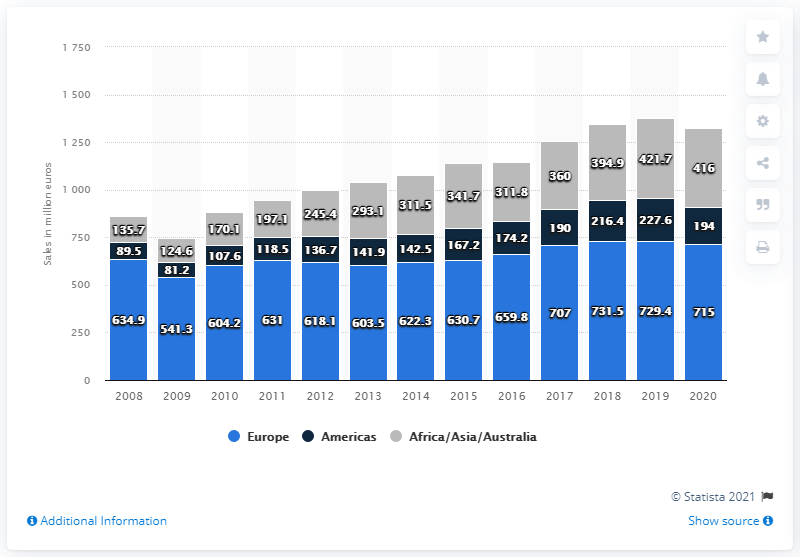Give some essential details in this illustration. In 2020, the tesa Group generated a total revenue of 416 in Africa, Asia, and Australia. The value of the tesa Group in 2020 was 729.4 (dollar/euro/etc.). The sales of the tesa Group in Europe in 2020 were 715... 